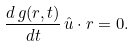<formula> <loc_0><loc_0><loc_500><loc_500>\frac { d \, g ( r , t ) } { d t } \, \hat { u } \cdot r = 0 .</formula> 